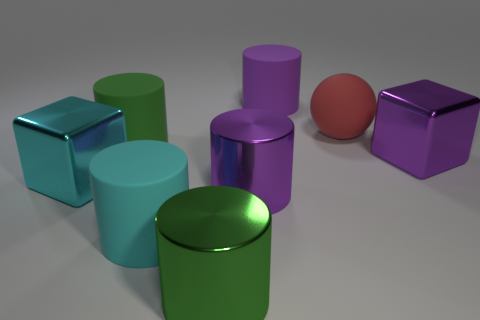There is another large thing that is the same shape as the big cyan metal thing; what material is it?
Keep it short and to the point. Metal. There is a metallic cylinder in front of the big cyan matte cylinder; what is its color?
Give a very brief answer. Green. What size is the purple shiny cylinder?
Provide a succinct answer. Large. There is a cyan cylinder; is it the same size as the purple thing in front of the purple metallic cube?
Give a very brief answer. Yes. The block that is right of the green object that is in front of the purple object that is in front of the big purple block is what color?
Your answer should be very brief. Purple. Are the green thing that is on the right side of the green rubber cylinder and the big ball made of the same material?
Offer a very short reply. No. What number of other objects are the same material as the red ball?
Your answer should be compact. 3. There is a red sphere that is the same size as the green rubber thing; what is its material?
Make the answer very short. Rubber. There is a large green object that is behind the big cyan block; is it the same shape as the rubber thing that is behind the big rubber ball?
Offer a terse response. Yes. The red rubber object that is the same size as the cyan metallic object is what shape?
Offer a terse response. Sphere. 